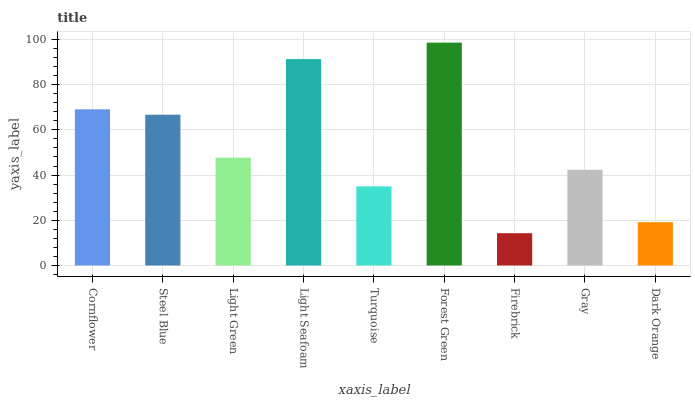Is Firebrick the minimum?
Answer yes or no. Yes. Is Forest Green the maximum?
Answer yes or no. Yes. Is Steel Blue the minimum?
Answer yes or no. No. Is Steel Blue the maximum?
Answer yes or no. No. Is Cornflower greater than Steel Blue?
Answer yes or no. Yes. Is Steel Blue less than Cornflower?
Answer yes or no. Yes. Is Steel Blue greater than Cornflower?
Answer yes or no. No. Is Cornflower less than Steel Blue?
Answer yes or no. No. Is Light Green the high median?
Answer yes or no. Yes. Is Light Green the low median?
Answer yes or no. Yes. Is Cornflower the high median?
Answer yes or no. No. Is Forest Green the low median?
Answer yes or no. No. 